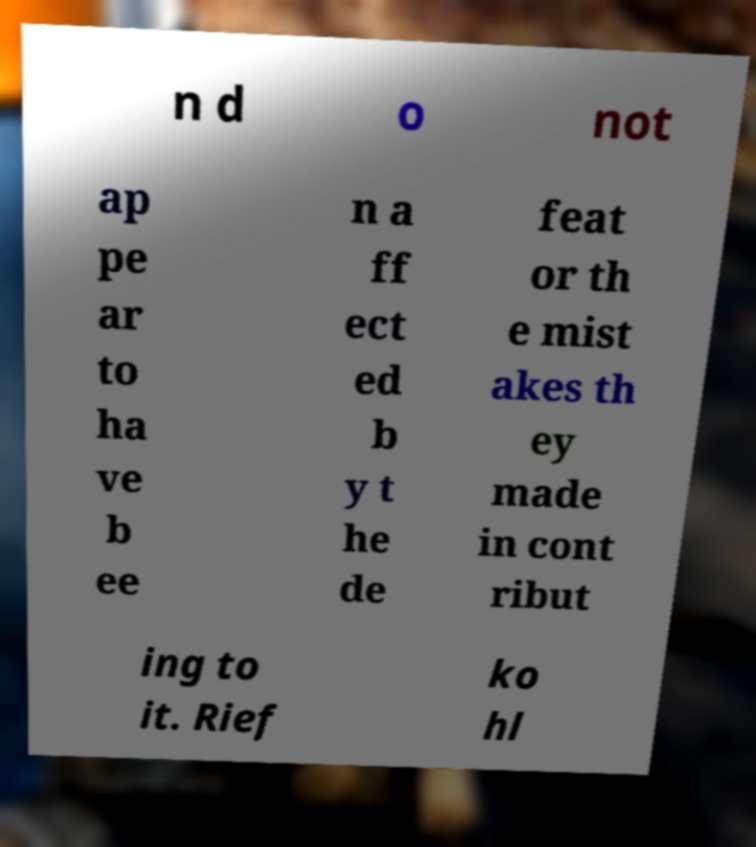There's text embedded in this image that I need extracted. Can you transcribe it verbatim? n d o not ap pe ar to ha ve b ee n a ff ect ed b y t he de feat or th e mist akes th ey made in cont ribut ing to it. Rief ko hl 